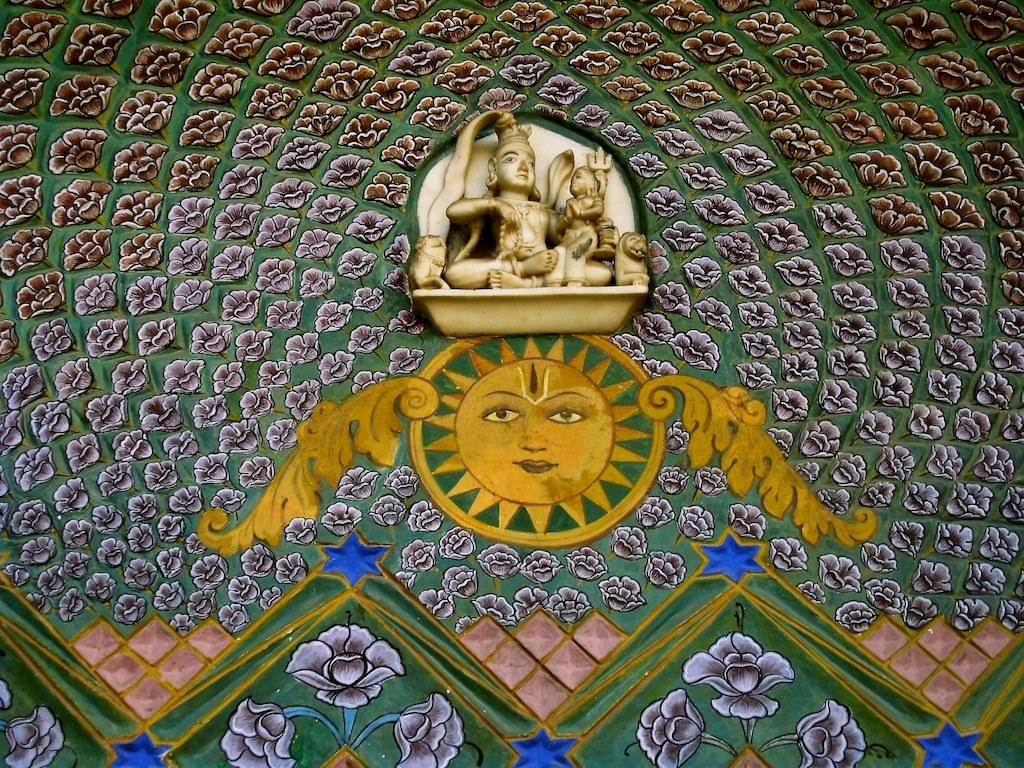What is present on the wall in the image? There is a sculpture and different types of paintings on the wall in the image. Can you describe the sculpture on the wall? Unfortunately, the specific details of the sculpture cannot be determined from the provided facts. What types of paintings are on the wall? The types of paintings on the wall cannot be determined from the provided facts. Are there any curtains hanging near the wall in the image? There is no mention of curtains in the provided facts, so we cannot determine if any are present in the image. Is there a letter addressed to someone on the wall in the image? There is no mention of a letter in the provided facts, so we cannot determine if one is present in the image. 